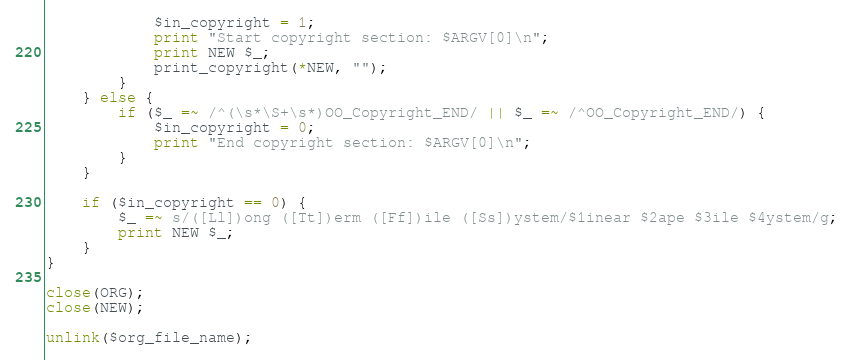Convert code to text. <code><loc_0><loc_0><loc_500><loc_500><_Perl_>            $in_copyright = 1;
            print "Start copyright section: $ARGV[0]\n";
            print NEW $_;
            print_copyright(*NEW, "");
        }
    } else {
        if ($_ =~ /^(\s*\S+\s*)OO_Copyright_END/ || $_ =~ /^OO_Copyright_END/) {
            $in_copyright = 0;
            print "End copyright section: $ARGV[0]\n";
        }
    }

    if ($in_copyright == 0) {
        $_ =~ s/([Ll])ong ([Tt])erm ([Ff])ile ([Ss])ystem/$1inear $2ape $3ile $4ystem/g;
        print NEW $_;
    }
}

close(ORG);
close(NEW);

unlink($org_file_name);
</code> 